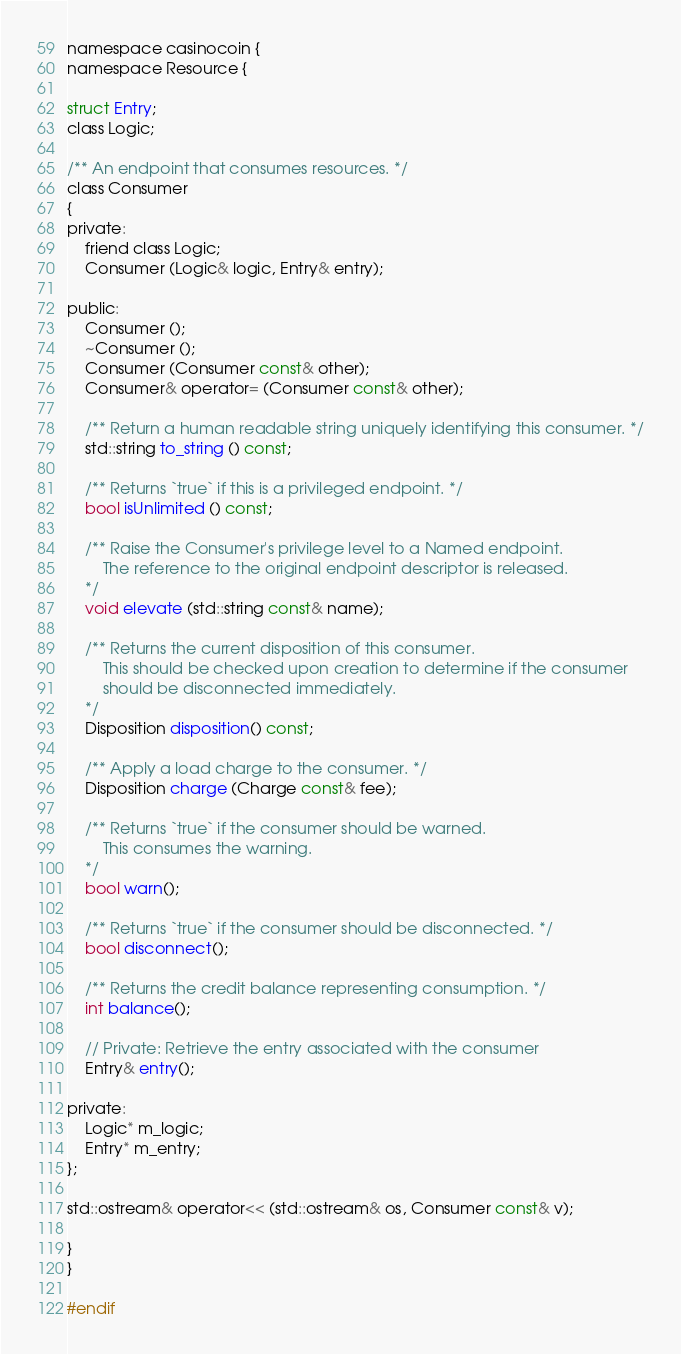<code> <loc_0><loc_0><loc_500><loc_500><_C_>namespace casinocoin {
namespace Resource {

struct Entry;
class Logic;

/** An endpoint that consumes resources. */
class Consumer
{
private:
    friend class Logic;
    Consumer (Logic& logic, Entry& entry);

public:
    Consumer ();
    ~Consumer ();
    Consumer (Consumer const& other);
    Consumer& operator= (Consumer const& other);

    /** Return a human readable string uniquely identifying this consumer. */
    std::string to_string () const;

    /** Returns `true` if this is a privileged endpoint. */
    bool isUnlimited () const;

    /** Raise the Consumer's privilege level to a Named endpoint.
        The reference to the original endpoint descriptor is released.
    */
    void elevate (std::string const& name);

    /** Returns the current disposition of this consumer.
        This should be checked upon creation to determine if the consumer
        should be disconnected immediately.
    */
    Disposition disposition() const;

    /** Apply a load charge to the consumer. */
    Disposition charge (Charge const& fee);

    /** Returns `true` if the consumer should be warned.
        This consumes the warning.
    */
    bool warn();

    /** Returns `true` if the consumer should be disconnected. */
    bool disconnect();

    /** Returns the credit balance representing consumption. */
    int balance();

    // Private: Retrieve the entry associated with the consumer
    Entry& entry();

private:
    Logic* m_logic;
    Entry* m_entry;
};

std::ostream& operator<< (std::ostream& os, Consumer const& v);

}
}

#endif
</code> 